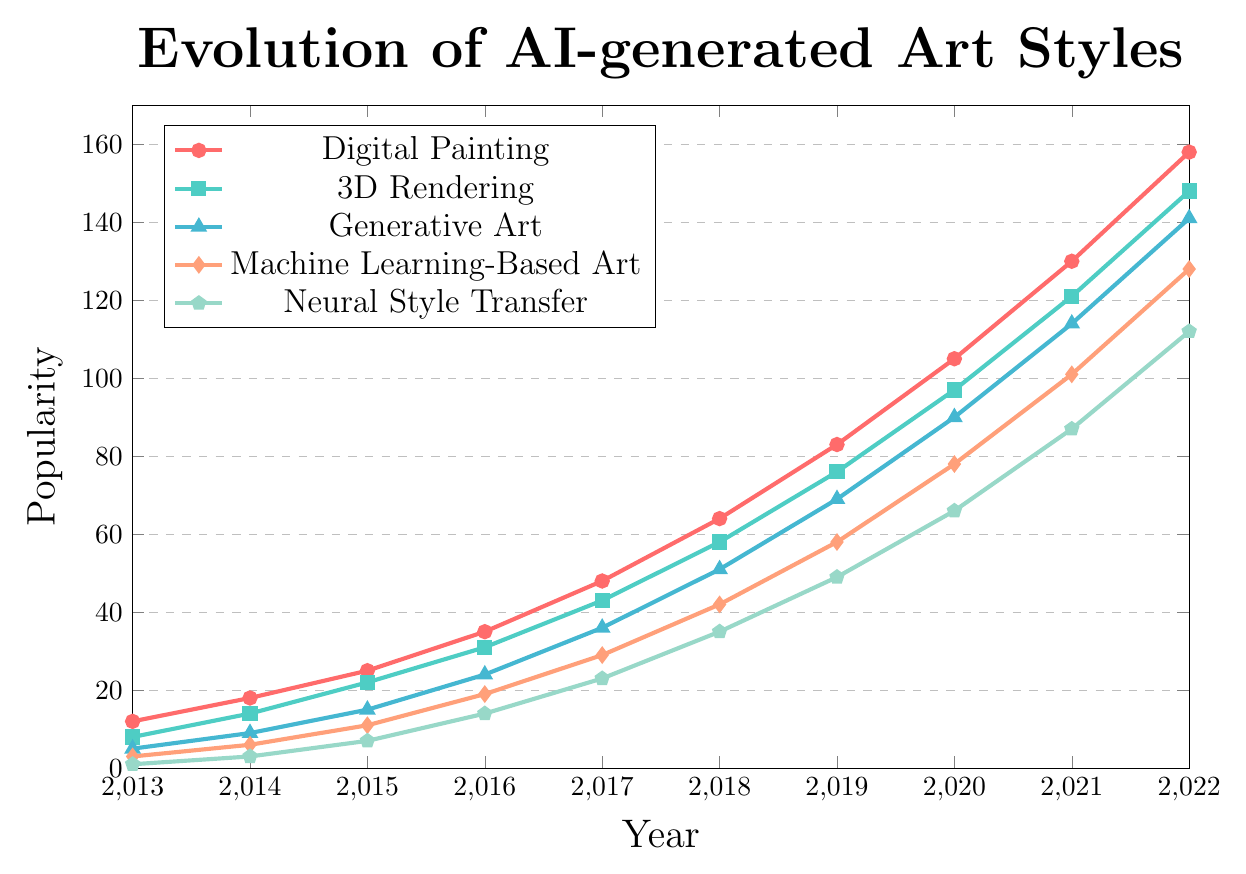what is the difference in popularity between Digital Painting and Neural Style Transfer in 2022? To determine the difference in popularity between Digital Painting and Neural Style Transfer in 2022, compare their values for the year. In 2022, Digital Painting is at 158 and Neural Style Transfer is at 112. The difference in popularity is 158 - 112 = 46
Answer: 46 Which art style shows the greatest increase in popularity from 2013 to 2022? To find the art style with the greatest increase, calculate the difference for each style from 2013 to 2022: Digital Painting (158 - 12 = 146), 3D Rendering (148 - 8 = 140), Generative Art (141 - 5 = 136), Machine Learning-Based Art (128 - 3 = 125), Neural Style Transfer (112 - 1 = 111). Digital Painting has the greatest increase.
Answer: Digital Painting In which year did Generative Art surpass the popularity of Machine Learning-Based Art? Scan the data points to see when Generative Art's value exceeded that of Machine Learning-Based Art. By comparing yearly values, Generative Art surpasses Machine Learning-Based Art in 2014 (9 vs 6).
Answer: 2014 What is the average popularity of 3D Rendering from 2013 to 2022? Sum the popularity of 3D Rendering for all years and divide by the number of years. (8 + 14 + 22 + 31 + 43 + 58 + 76 + 97 + 121 + 148) / 10 = 618 / 10 = 61.8
Answer: 61.8 Which art style had the lowest popularity in 2017? In 2017, compare the popularity of the art styles. Digital Painting (48), 3D Rendering (43), Generative Art (36), Machine Learning-Based Art (29), Neural Style Transfer (23). Neural Style Transfer is the lowest.
Answer: Neural Style Transfer How many more units of popularity did Digital Painting have compared to 3D Rendering in 2020? Compare the popularity in 2020: Digital Painting (105), 3D Rendering (97). The difference is 105 - 97 = 8
Answer: 8 Was there any year when Machine Learning-Based Art had exactly twice the popularity of Neural Style Transfer? Examine each year’s values to match double the Neural Style Transfer value with Machine Learning-Based Art. In 2016, Machine Learning-Based Art (19) is exactly twice Neural Style Transfer (14).
Answer: No Which art style had the steepest growth between 2018 and 2019? Calculate the growth for each style from 2018 to 2019: Digital Painting (83 - 64 = 19), 3D Rendering (76 - 58 = 18), Generative Art (69 - 51 = 18), Machine Learning-Based Art (58 - 42 = 16), Neural Style Transfer (49 - 35 = 14). Digital Painting had the steepest growth.
Answer: Digital Painting 